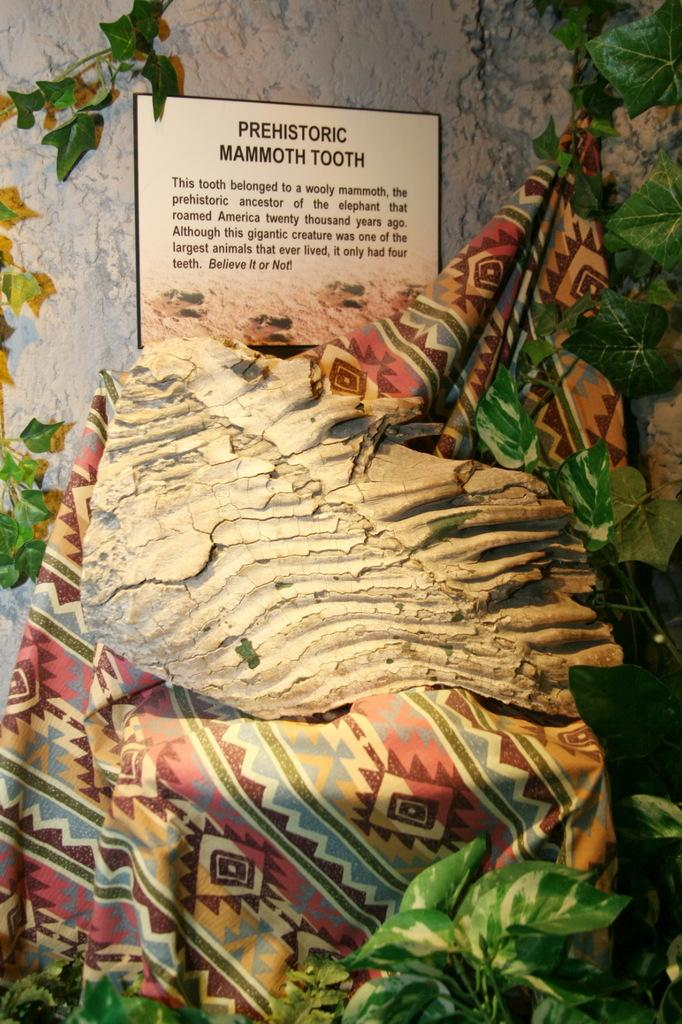<image>
Create a compact narrative representing the image presented. A display features a Prehistoric Mammoth Tooth on a piece of cloth. 